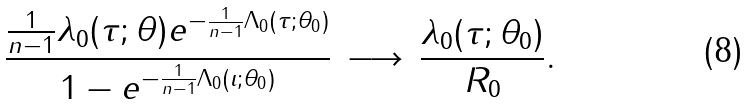<formula> <loc_0><loc_0><loc_500><loc_500>\frac { \frac { 1 } { n - 1 } \lambda _ { 0 } ( \tau ; \theta ) e ^ { - \frac { 1 } { n - 1 } \Lambda _ { 0 } ( \tau ; \theta _ { 0 } ) } } { 1 - e ^ { - \frac { 1 } { n - 1 } \Lambda _ { 0 } ( \iota ; \theta _ { 0 } ) } } \, \longrightarrow \, \frac { \lambda _ { 0 } ( \tau ; \theta _ { 0 } ) } { R _ { 0 } } .</formula> 